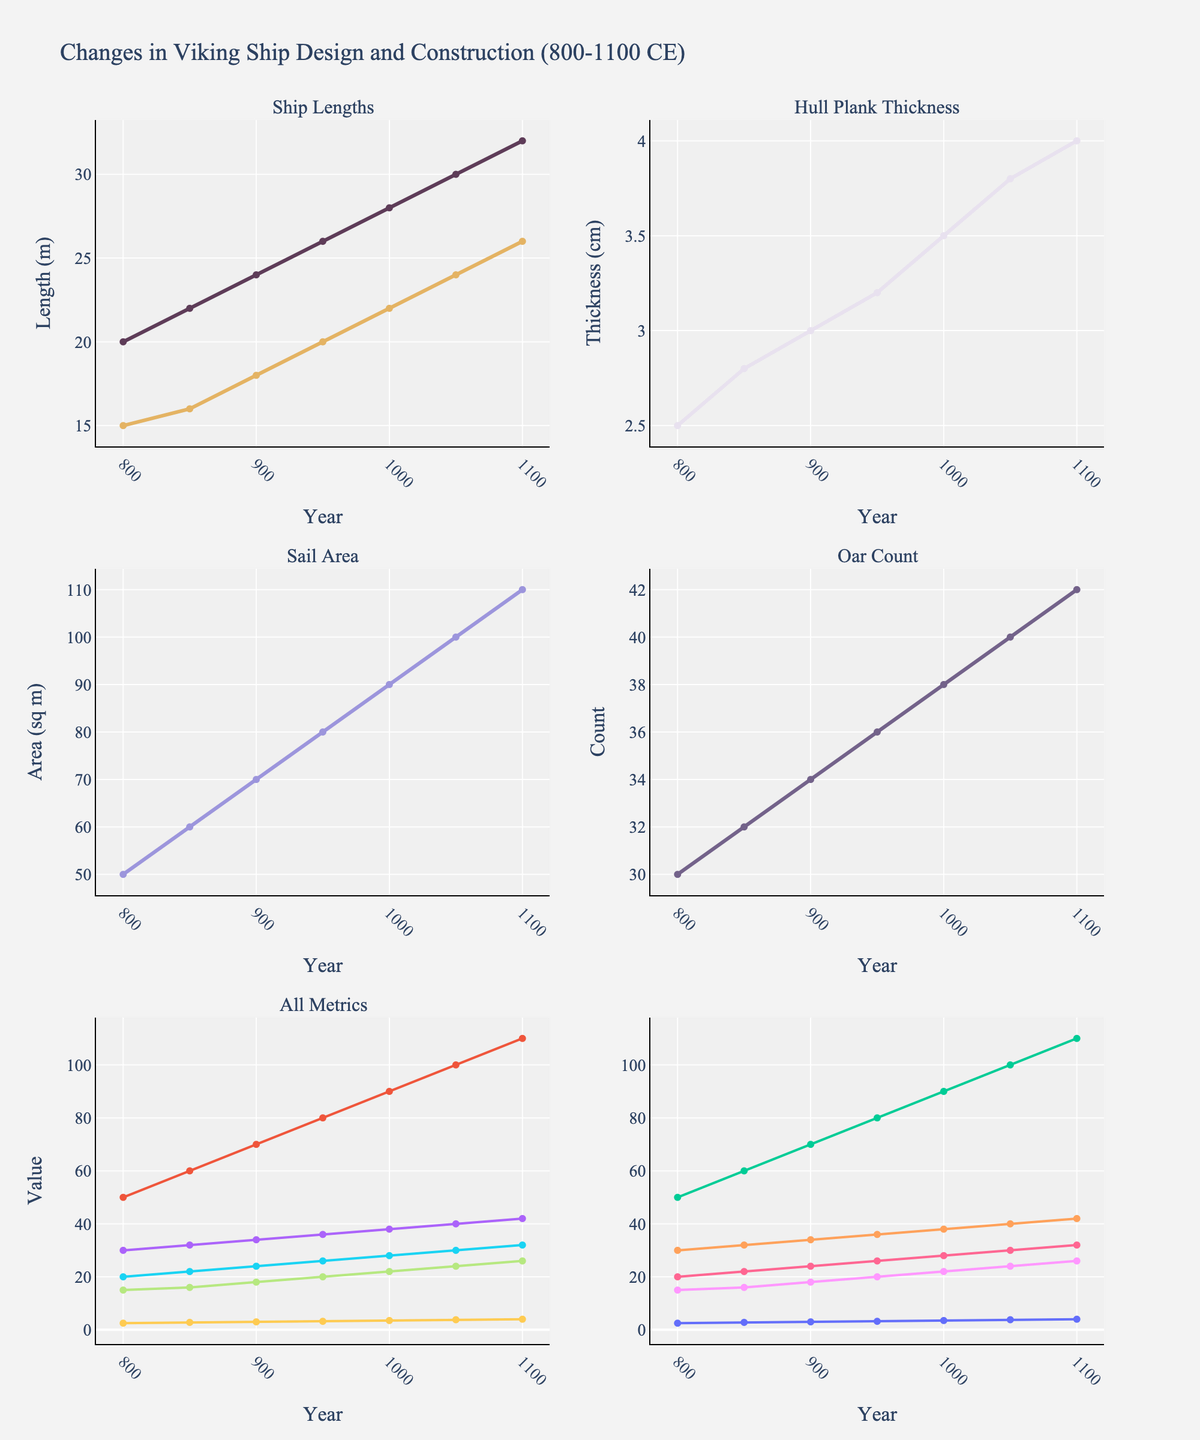What is the title of the figure? The title is located at the top center of the figure and is typically the first text you see. It describes the main focus of the data visualized.
Answer: Changes in Viking Ship Design and Construction (800-1100 CE) How does the length of Longships and Knarrs change over time from 800 to 1100 CE? By examining the lines in the first subplot, we can see that the lengths of both Longships and Knarrs show a consistent upward trend over the specified time period. Longship length increases from 20 m to 32 m, and Knarr length increases from 15 m to 26 m.
Answer: Both lengths increase Which ship type experienced a greater absolute increase in length, the Longship or the Knarr, from 800 to 1100 CE? By calculating the difference between the starting and ending lengths (32 m - 20 m for Longships, 26 m - 15 m for Knarrs), we find the increase for Longships is 12 m and for Knarrs is 11 m.
Answer: Longship What is the trend in hull plank thickness from 800 to 1100 CE? Observing the second subplot, the line for hull plank thickness shows a steady increase over time, starting from 2.5 cm in 800 CE and reaching 4.0 cm in 1100 CE.
Answer: Steadily increasing How many oars did Viking ships have around 950 CE? By locating the year 950 CE on the x-axis in the Oar Count subplot and tracing upwards, we find the number of oars at this time is 36.
Answer: 36 Which metric shows the most significant increase when comparing its initial and final values, Sail Area or Oar Count? Moving to the appropriate subplots, both metrics show an increase. Calculating: Sail Area increases from 50 sq m to 110 sq m (increase of 60 sq m), and Oar Count increases from 30 to 42 (increase of 12). The Sail Area shows the more significant increase.
Answer: Sail Area Is there any subplot that displays all the metrics together? The bottom subplot labeled "All Metrics" contains all the lines representing the different metrics against the same time axis.
Answer: Yes, the subplot titled "All Metrics" What is the approximate year when the Sail Area reached 80 sq m? Observing the Sail Area line in its subplot, the Sail Area reaches 80 sq m around 950 CE.
Answer: Around 950 CE Does the Oar Count increase linearly over the years displayed? By examining the line in the Oar Count subplot, it appears to follow a linear upward trend as the intervals between the increases (30 to 32, 32 to 34, etc.) are roughly consistent.
Answer: Yes, it increases linearly 